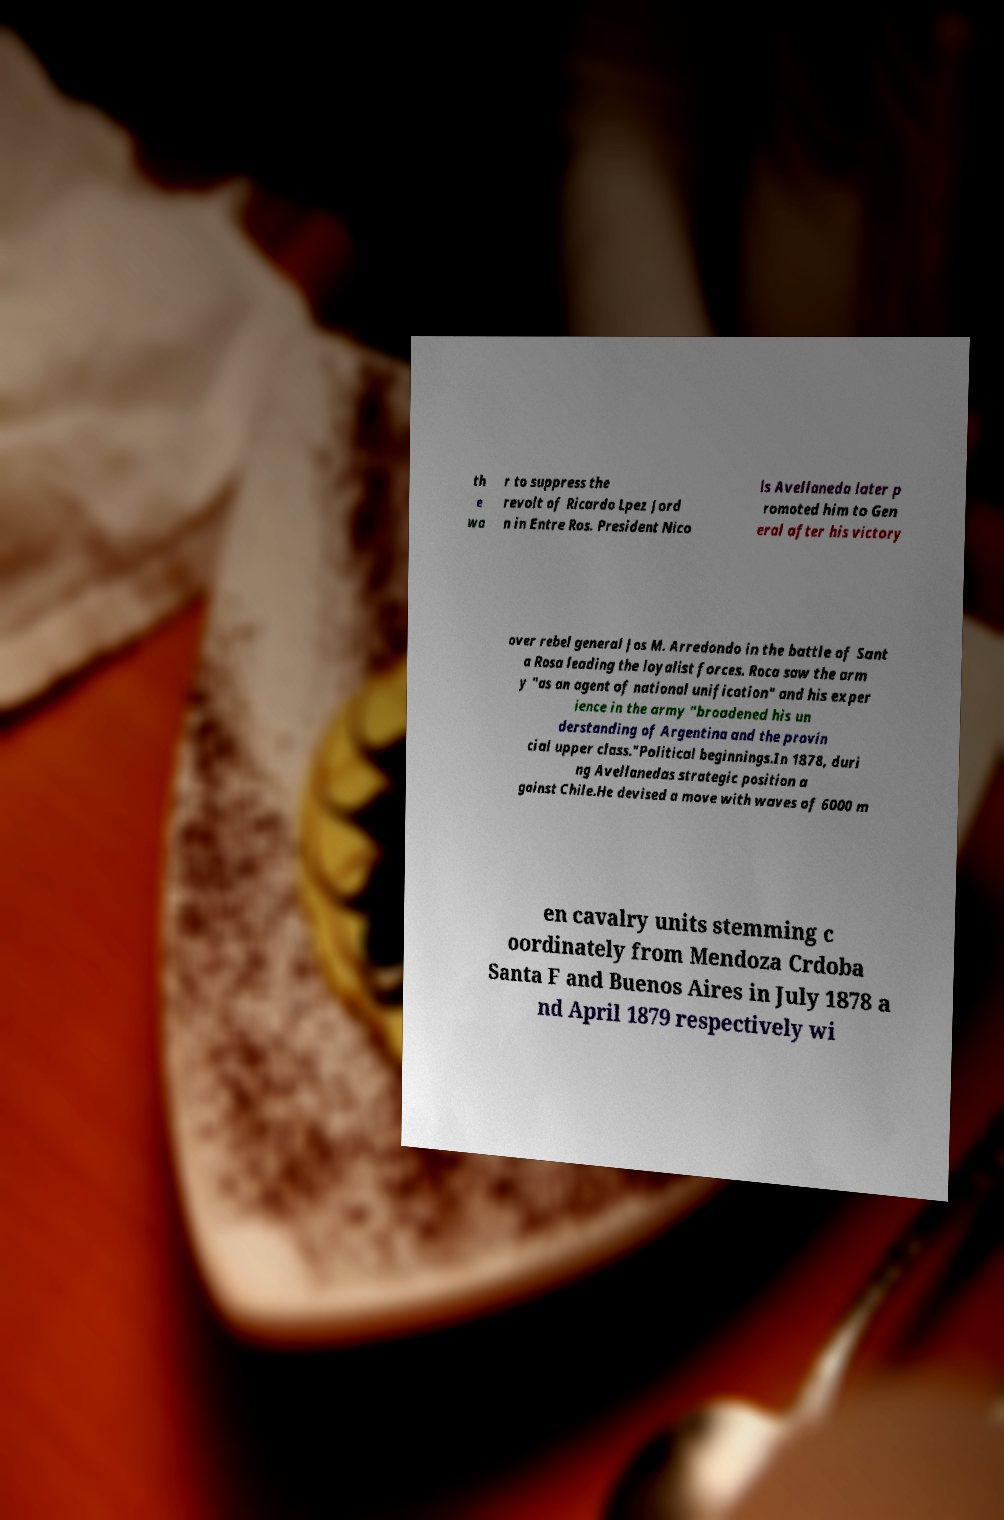What messages or text are displayed in this image? I need them in a readable, typed format. th e wa r to suppress the revolt of Ricardo Lpez Jord n in Entre Ros. President Nico ls Avellaneda later p romoted him to Gen eral after his victory over rebel general Jos M. Arredondo in the battle of Sant a Rosa leading the loyalist forces. Roca saw the arm y "as an agent of national unification" and his exper ience in the army "broadened his un derstanding of Argentina and the provin cial upper class."Political beginnings.In 1878, duri ng Avellanedas strategic position a gainst Chile.He devised a move with waves of 6000 m en cavalry units stemming c oordinately from Mendoza Crdoba Santa F and Buenos Aires in July 1878 a nd April 1879 respectively wi 